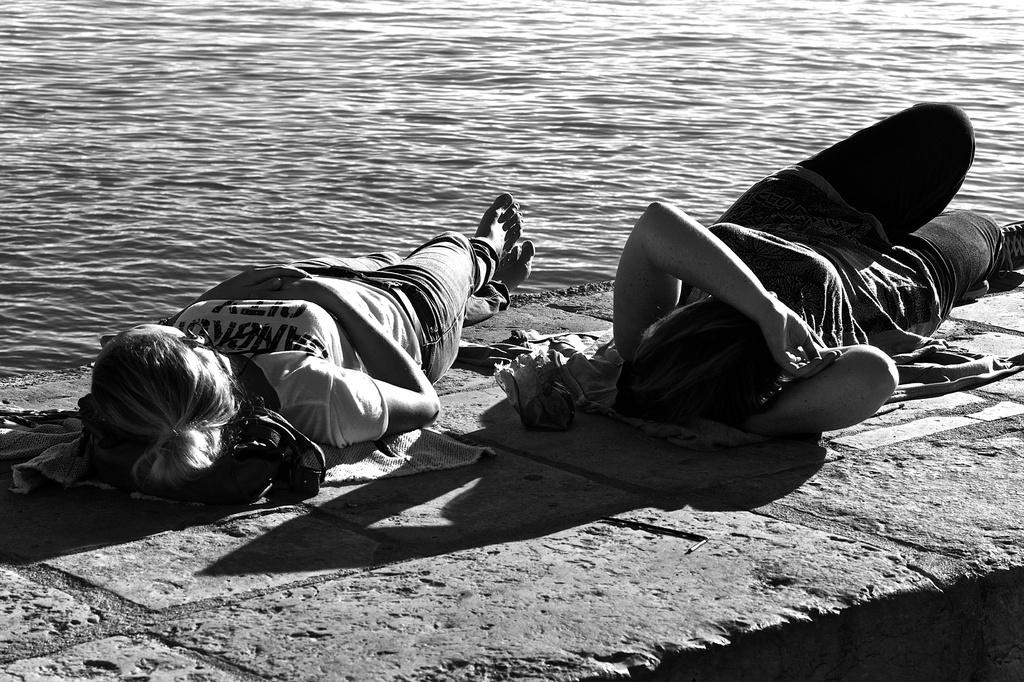How many people are in the image? There are two persons in the image. What are the persons doing in the image? The persons are lying on the pathway. What can be seen in the background of the image? There is water visible in the background of the image. What type of knife is being used by the person in the image? There is no knife present in the image. What time of day is it in the image? The time of day cannot be determined from the image alone. 